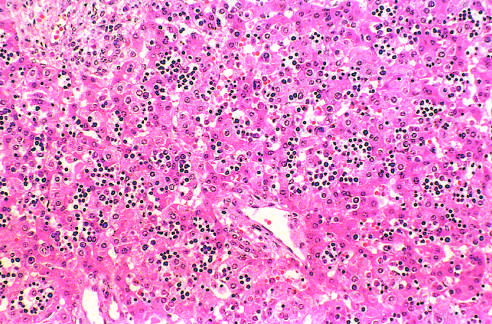what are scattered among mature hepatocytes in this histologic preparation from an infant with nonimmune hydrops fetalis?
Answer the question using a single word or phrase. Numerous islands of extramedullary hematopoiesis 